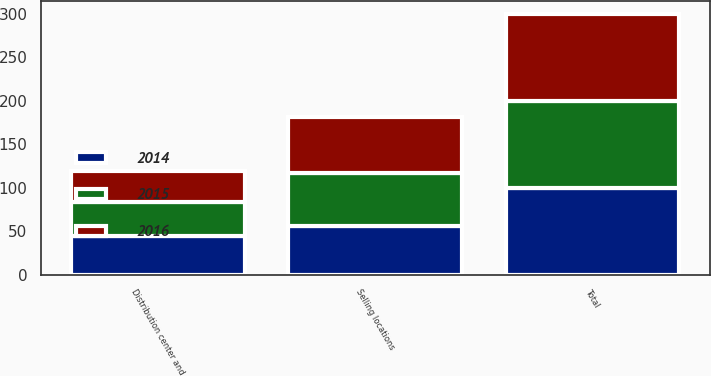Convert chart. <chart><loc_0><loc_0><loc_500><loc_500><stacked_bar_chart><ecel><fcel>Selling locations<fcel>Distribution center and<fcel>Total<nl><fcel>2016<fcel>64<fcel>36<fcel>100<nl><fcel>2015<fcel>61<fcel>39<fcel>100<nl><fcel>2014<fcel>56<fcel>44<fcel>100<nl></chart> 